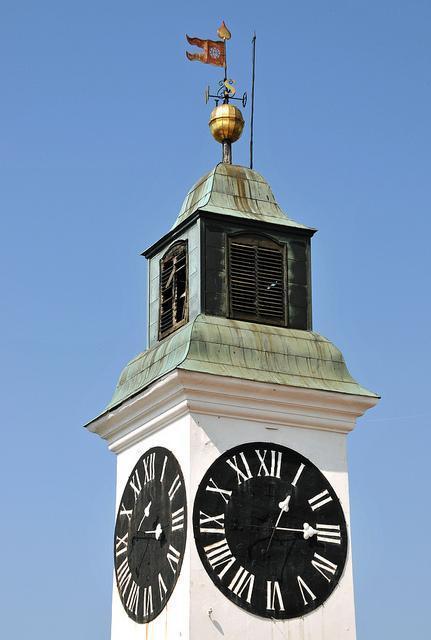How many clocks are visible?
Give a very brief answer. 2. 